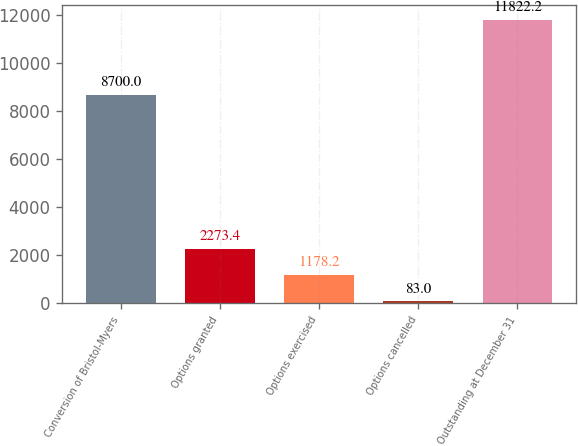<chart> <loc_0><loc_0><loc_500><loc_500><bar_chart><fcel>Conversion of Bristol-Myers<fcel>Options granted<fcel>Options exercised<fcel>Options cancelled<fcel>Outstanding at December 31<nl><fcel>8700<fcel>2273.4<fcel>1178.2<fcel>83<fcel>11822.2<nl></chart> 